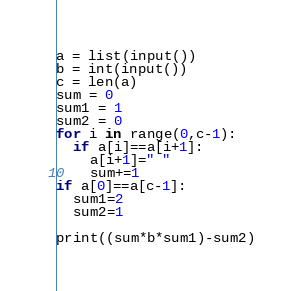Convert code to text. <code><loc_0><loc_0><loc_500><loc_500><_Python_>a = list(input())
b = int(input())
c = len(a)
sum = 0
sum1 = 1
sum2 = 0
for i in range(0,c-1):
  if a[i]==a[i+1]:
    a[i+1]=" "
    sum+=1
if a[0]==a[c-1]:
  sum1=2
  sum2=1
      
print((sum*b*sum1)-sum2)

</code> 